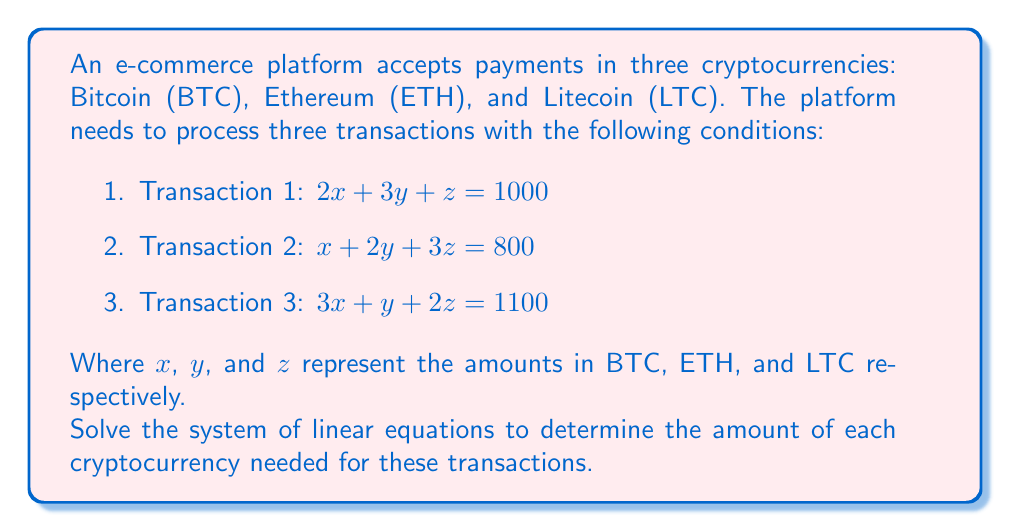Teach me how to tackle this problem. To solve this system of linear equations, we'll use the Gaussian elimination method:

Step 1: Write the augmented matrix for the system of equations:
$$
\begin{bmatrix}
2 & 3 & 1 & 1000 \\
1 & 2 & 3 & 800 \\
3 & 1 & 2 & 1100
\end{bmatrix}
$$

Step 2: Use row operations to transform the matrix into row echelon form:

a) Multiply row 1 by -1 and add it to row 2:
$$
\begin{bmatrix}
2 & 3 & 1 & 1000 \\
0 & \frac{1}{2} & \frac{5}{2} & 300 \\
3 & 1 & 2 & 1100
\end{bmatrix}
$$

b) Multiply row 1 by -3/2 and add it to row 3:
$$
\begin{bmatrix}
2 & 3 & 1 & 1000 \\
0 & \frac{1}{2} & \frac{5}{2} & 300 \\
0 & -\frac{7}{2} & \frac{1}{2} & -400
\end{bmatrix}
$$

Step 3: Continue row operations to achieve reduced row echelon form:

a) Multiply row 2 by 2:
$$
\begin{bmatrix}
2 & 3 & 1 & 1000 \\
0 & 1 & 5 & 600 \\
0 & -\frac{7}{2} & \frac{1}{2} & -400
\end{bmatrix}
$$

b) Multiply row 2 by 7/2 and add it to row 3:
$$
\begin{bmatrix}
2 & 3 & 1 & 1000 \\
0 & 1 & 5 & 600 \\
0 & 0 & 18 & 1700
\end{bmatrix}
$$

Step 4: Solve for z, y, and x:

a) $z = 1700 / 18 = 94.44...$

b) Substitute z in row 2: $y + 5(94.44...) = 600$
   $y = 600 - 472.22... = 127.78...$

c) Substitute y and z in row 1: $2x + 3(127.78...) + 94.44... = 1000$
   $2x = 1000 - 383.33... - 94.44... = 522.22...$
   $x = 261.11...$

Step 5: Round the results to two decimal places:
$x = 261.11$
$y = 127.78$
$z = 94.44$
Answer: BTC: $261.11, ETH: $127.78, LTC: $94.44 